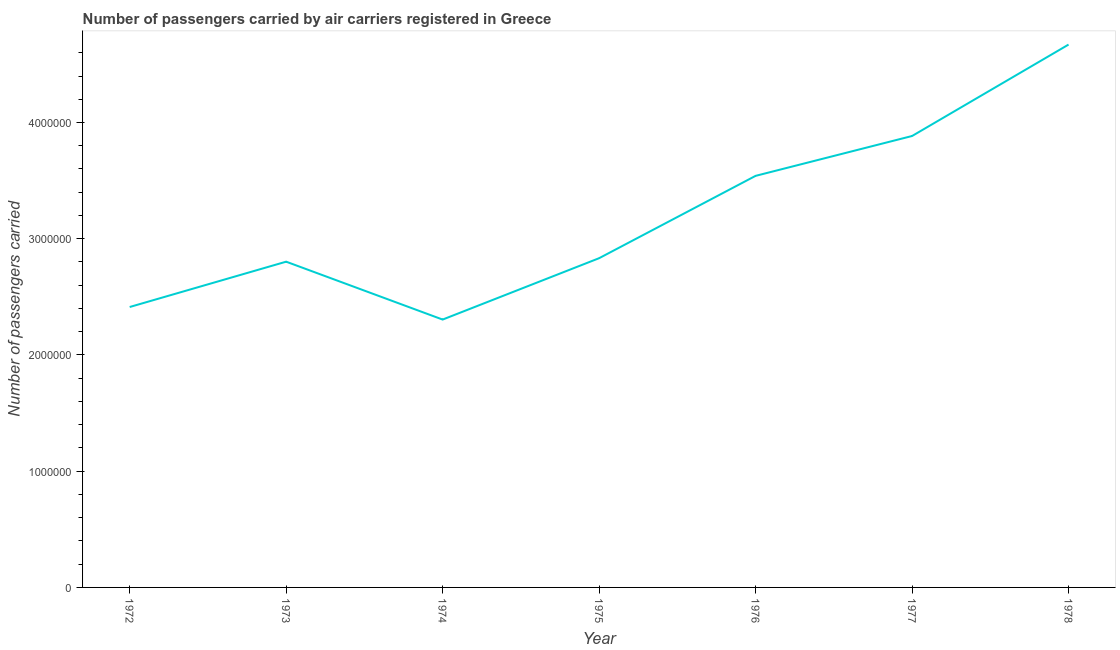What is the number of passengers carried in 1978?
Your answer should be very brief. 4.67e+06. Across all years, what is the maximum number of passengers carried?
Provide a short and direct response. 4.67e+06. Across all years, what is the minimum number of passengers carried?
Ensure brevity in your answer.  2.30e+06. In which year was the number of passengers carried maximum?
Provide a succinct answer. 1978. In which year was the number of passengers carried minimum?
Provide a succinct answer. 1974. What is the sum of the number of passengers carried?
Ensure brevity in your answer.  2.24e+07. What is the difference between the number of passengers carried in 1977 and 1978?
Provide a succinct answer. -7.87e+05. What is the average number of passengers carried per year?
Your answer should be very brief. 3.21e+06. What is the median number of passengers carried?
Offer a very short reply. 2.83e+06. In how many years, is the number of passengers carried greater than 400000 ?
Keep it short and to the point. 7. Do a majority of the years between 1972 and 1978 (inclusive) have number of passengers carried greater than 2600000 ?
Your answer should be very brief. Yes. What is the ratio of the number of passengers carried in 1973 to that in 1976?
Keep it short and to the point. 0.79. Is the number of passengers carried in 1972 less than that in 1973?
Your response must be concise. Yes. What is the difference between the highest and the second highest number of passengers carried?
Your answer should be compact. 7.87e+05. Is the sum of the number of passengers carried in 1974 and 1975 greater than the maximum number of passengers carried across all years?
Offer a terse response. Yes. What is the difference between the highest and the lowest number of passengers carried?
Ensure brevity in your answer.  2.37e+06. In how many years, is the number of passengers carried greater than the average number of passengers carried taken over all years?
Provide a short and direct response. 3. Does the number of passengers carried monotonically increase over the years?
Offer a very short reply. No. What is the difference between two consecutive major ticks on the Y-axis?
Your response must be concise. 1.00e+06. Are the values on the major ticks of Y-axis written in scientific E-notation?
Make the answer very short. No. Does the graph contain any zero values?
Provide a short and direct response. No. Does the graph contain grids?
Keep it short and to the point. No. What is the title of the graph?
Keep it short and to the point. Number of passengers carried by air carriers registered in Greece. What is the label or title of the X-axis?
Your response must be concise. Year. What is the label or title of the Y-axis?
Make the answer very short. Number of passengers carried. What is the Number of passengers carried in 1972?
Provide a short and direct response. 2.41e+06. What is the Number of passengers carried in 1973?
Your response must be concise. 2.80e+06. What is the Number of passengers carried in 1974?
Your answer should be very brief. 2.30e+06. What is the Number of passengers carried in 1975?
Provide a succinct answer. 2.83e+06. What is the Number of passengers carried of 1976?
Your answer should be compact. 3.54e+06. What is the Number of passengers carried in 1977?
Ensure brevity in your answer.  3.88e+06. What is the Number of passengers carried of 1978?
Make the answer very short. 4.67e+06. What is the difference between the Number of passengers carried in 1972 and 1973?
Your answer should be compact. -3.90e+05. What is the difference between the Number of passengers carried in 1972 and 1974?
Provide a short and direct response. 1.08e+05. What is the difference between the Number of passengers carried in 1972 and 1975?
Offer a very short reply. -4.20e+05. What is the difference between the Number of passengers carried in 1972 and 1976?
Make the answer very short. -1.13e+06. What is the difference between the Number of passengers carried in 1972 and 1977?
Ensure brevity in your answer.  -1.47e+06. What is the difference between the Number of passengers carried in 1972 and 1978?
Offer a very short reply. -2.26e+06. What is the difference between the Number of passengers carried in 1973 and 1974?
Give a very brief answer. 4.98e+05. What is the difference between the Number of passengers carried in 1973 and 1975?
Make the answer very short. -3.00e+04. What is the difference between the Number of passengers carried in 1973 and 1976?
Your response must be concise. -7.38e+05. What is the difference between the Number of passengers carried in 1973 and 1977?
Give a very brief answer. -1.08e+06. What is the difference between the Number of passengers carried in 1973 and 1978?
Provide a short and direct response. -1.87e+06. What is the difference between the Number of passengers carried in 1974 and 1975?
Offer a very short reply. -5.28e+05. What is the difference between the Number of passengers carried in 1974 and 1976?
Make the answer very short. -1.24e+06. What is the difference between the Number of passengers carried in 1974 and 1977?
Provide a short and direct response. -1.58e+06. What is the difference between the Number of passengers carried in 1974 and 1978?
Your answer should be compact. -2.37e+06. What is the difference between the Number of passengers carried in 1975 and 1976?
Your answer should be compact. -7.08e+05. What is the difference between the Number of passengers carried in 1975 and 1977?
Provide a short and direct response. -1.05e+06. What is the difference between the Number of passengers carried in 1975 and 1978?
Give a very brief answer. -1.84e+06. What is the difference between the Number of passengers carried in 1976 and 1977?
Give a very brief answer. -3.43e+05. What is the difference between the Number of passengers carried in 1976 and 1978?
Give a very brief answer. -1.13e+06. What is the difference between the Number of passengers carried in 1977 and 1978?
Provide a succinct answer. -7.87e+05. What is the ratio of the Number of passengers carried in 1972 to that in 1973?
Provide a succinct answer. 0.86. What is the ratio of the Number of passengers carried in 1972 to that in 1974?
Your answer should be compact. 1.05. What is the ratio of the Number of passengers carried in 1972 to that in 1975?
Keep it short and to the point. 0.85. What is the ratio of the Number of passengers carried in 1972 to that in 1976?
Offer a terse response. 0.68. What is the ratio of the Number of passengers carried in 1972 to that in 1977?
Ensure brevity in your answer.  0.62. What is the ratio of the Number of passengers carried in 1972 to that in 1978?
Your response must be concise. 0.52. What is the ratio of the Number of passengers carried in 1973 to that in 1974?
Offer a very short reply. 1.22. What is the ratio of the Number of passengers carried in 1973 to that in 1976?
Keep it short and to the point. 0.79. What is the ratio of the Number of passengers carried in 1973 to that in 1977?
Your answer should be very brief. 0.72. What is the ratio of the Number of passengers carried in 1974 to that in 1975?
Ensure brevity in your answer.  0.81. What is the ratio of the Number of passengers carried in 1974 to that in 1976?
Make the answer very short. 0.65. What is the ratio of the Number of passengers carried in 1974 to that in 1977?
Provide a succinct answer. 0.59. What is the ratio of the Number of passengers carried in 1974 to that in 1978?
Your response must be concise. 0.49. What is the ratio of the Number of passengers carried in 1975 to that in 1977?
Make the answer very short. 0.73. What is the ratio of the Number of passengers carried in 1975 to that in 1978?
Provide a short and direct response. 0.61. What is the ratio of the Number of passengers carried in 1976 to that in 1977?
Your response must be concise. 0.91. What is the ratio of the Number of passengers carried in 1976 to that in 1978?
Provide a short and direct response. 0.76. What is the ratio of the Number of passengers carried in 1977 to that in 1978?
Give a very brief answer. 0.83. 